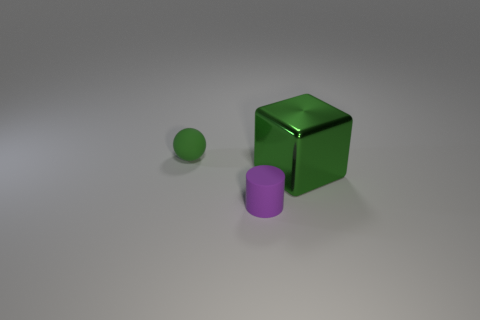Are there any other things that have the same material as the big green thing?
Ensure brevity in your answer.  No. How many other things are the same material as the cube?
Your response must be concise. 0. What color is the small object behind the small matte cylinder?
Ensure brevity in your answer.  Green. There is a green thing that is on the right side of the rubber thing that is behind the green thing in front of the green matte ball; what is its material?
Make the answer very short. Metal. Are there any red rubber objects that have the same shape as the purple object?
Your answer should be compact. No. What shape is the rubber thing that is the same size as the cylinder?
Provide a short and direct response. Sphere. How many things are both in front of the small sphere and left of the big block?
Make the answer very short. 1. Is the number of small purple cylinders that are left of the small green thing less than the number of big gray metal spheres?
Provide a succinct answer. No. Are there any other green metal blocks of the same size as the metallic cube?
Ensure brevity in your answer.  No. The thing that is the same material as the cylinder is what color?
Give a very brief answer. Green. 